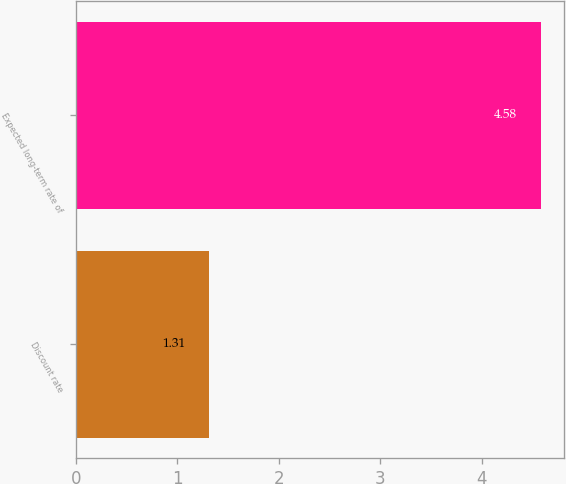Convert chart. <chart><loc_0><loc_0><loc_500><loc_500><bar_chart><fcel>Discount rate<fcel>Expected long-term rate of<nl><fcel>1.31<fcel>4.58<nl></chart> 